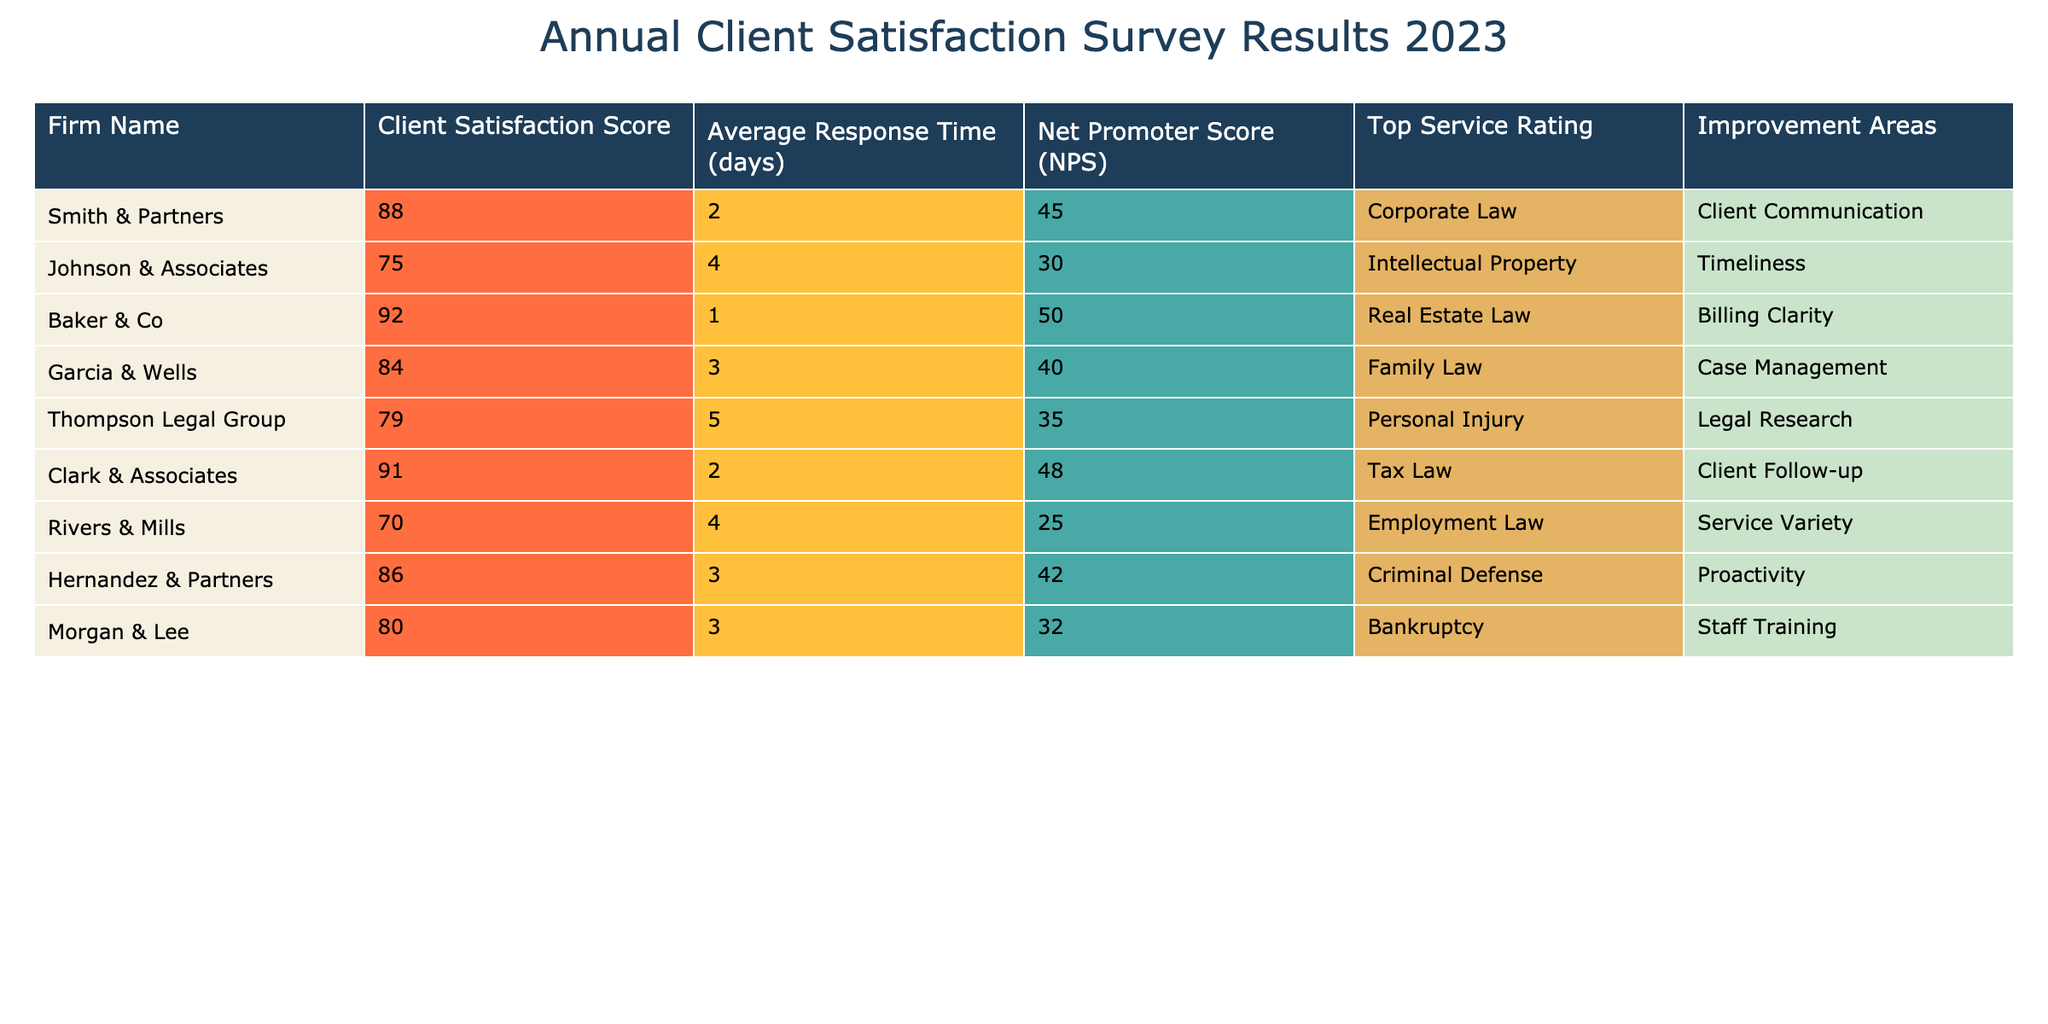What is the client satisfaction score for Baker & Co? The client satisfaction score for Baker & Co is directly listed in the table under the relevant column, which shows a score of 92.
Answer: 92 Which firm has the highest Net Promoter Score (NPS)? The table shows the NPS for all firms. Scanning down the column, Baker & Co has the highest NPS of 50.
Answer: Baker & Co How many firms have an average response time of 3 days? By examining the average response time column, we can count the firms with a response time of 3 days. There are three firms: Garcia & Wells, Hernandez & Partners, and Morgan & Lee.
Answer: 3 What is the difference between the client satisfaction score of Smith & Partners and Rivers & Mills? The client satisfaction score for Smith & Partners is 88 and for Rivers & Mills is 70. Calculating the difference: 88 - 70 = 18.
Answer: 18 Which improvement area is most commonly mentioned among the firms? Reviewing the improvement areas column, "Client Communication" appears once, while "Timeliness," "Billing Clarity," "Case Management," "Legal Research," "Service Variety," and "Staff Training" each appear once as well. None of the improvement areas are repeated across firms, making them all unique.
Answer: All improvement areas are unique Is the average response time of Johnson & Associates higher than that of Smith & Partners? The average response time for Johnson & Associates is 4 days and for Smith & Partners is 2 days. Since 4 is greater than 2, the statement is true.
Answer: Yes What is the total client satisfaction score of firms that practice Corporate and Family Law? The client satisfaction scores for Smith & Partners (Corporate Law) and Garcia & Wells (Family Law) are 88 and 84, respectively. Adding these scores together gives 88 + 84 = 172.
Answer: 172 Which firm has the lowest client satisfaction score and what is it? Scanning the client satisfaction scores, Rivers & Mills has the lowest score of 70, making it the firm with the lowest satisfaction.
Answer: Rivers & Mills, 70 Which firm's top service rating is Personal Injury and what is their NPS? The table indicates that the Thompson Legal Group has a top service rating of Personal Injury with an NPS of 35, making them the corresponding firm.
Answer: Thompson Legal Group, 35 